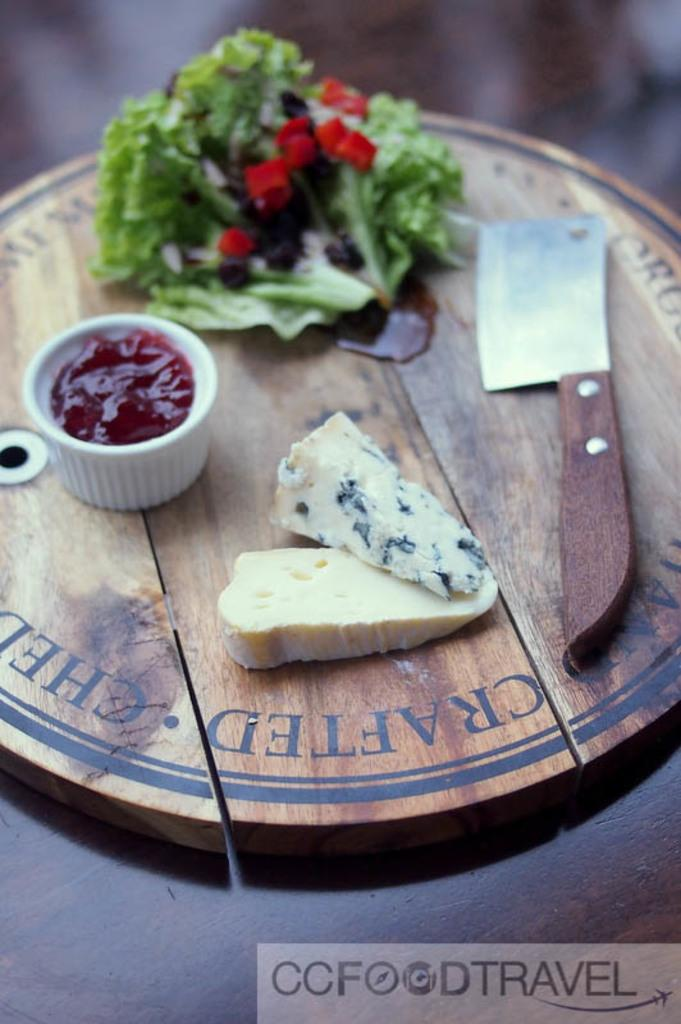What is the main object on the chopping board in the image? There is food present on the chopping board in the image. What type of vegetable can be seen in the image? There is a leafy vegetable in the image. What can be used to cut the food on the chopping board? There is a knife in the image. What is the purpose of the cup in the image? The purpose of the cup in the image is not clear, but it could be used for holding liquids or other items. What is written at the bottom of the image? There is some text at the bottom of the image. Where is the nearest park to the location of the image? The provided facts do not give any information about the location of the image, so it is impossible to determine the nearest park. What advice is given in the text at the bottom of the image? The provided facts do not give any information about the content of the text at the bottom of the image, so it is impossible to determine any advice given. 